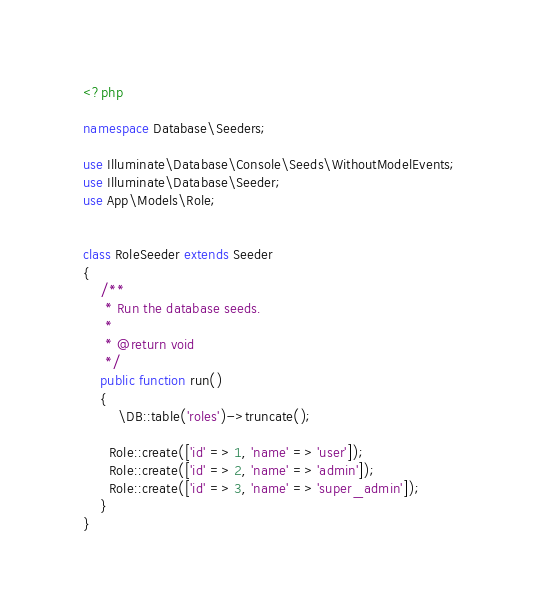Convert code to text. <code><loc_0><loc_0><loc_500><loc_500><_PHP_><?php

namespace Database\Seeders;

use Illuminate\Database\Console\Seeds\WithoutModelEvents;
use Illuminate\Database\Seeder;
use App\Models\Role;


class RoleSeeder extends Seeder
{
    /**
     * Run the database seeds.
     *
     * @return void
     */
    public function run()
    {
        \DB::table('roles')->truncate();

      Role::create(['id' => 1, 'name' => 'user']);
      Role::create(['id' => 2, 'name' => 'admin']);
      Role::create(['id' => 3, 'name' => 'super_admin']); 
    }
}
</code> 